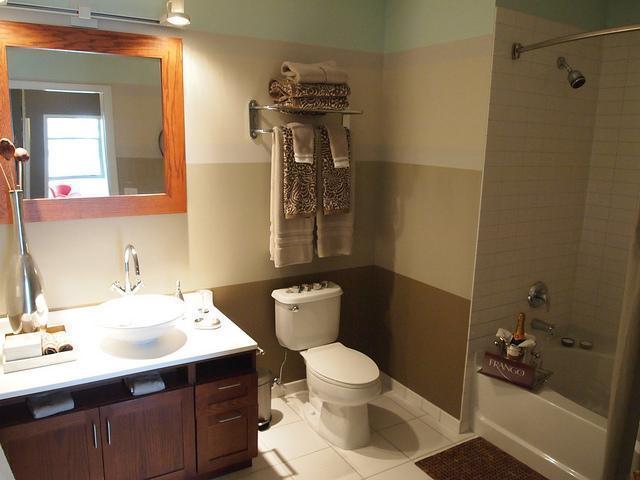What is on the rack sitting on the bathtub's edge?
From the following set of four choices, select the accurate answer to respond to the question.
Options: Conditioner, soap, shampoo, wine. Wine. What color is the border around the edges of the mirror?
From the following four choices, select the correct answer to address the question.
Options: Blue, wood, black, green. Wood. 